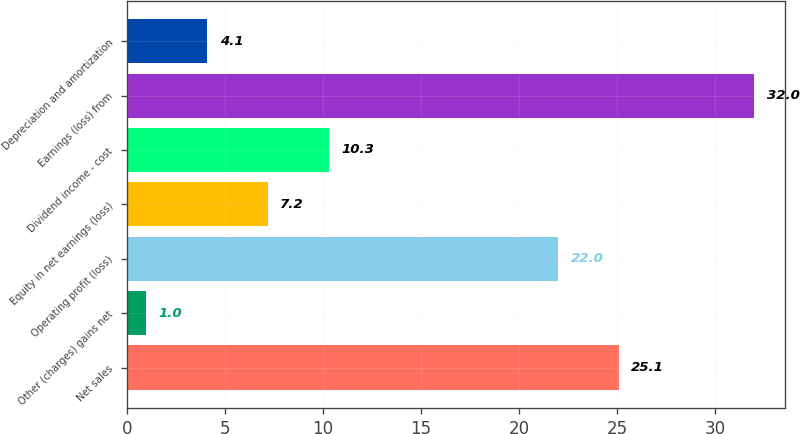Convert chart. <chart><loc_0><loc_0><loc_500><loc_500><bar_chart><fcel>Net sales<fcel>Other (charges) gains net<fcel>Operating profit (loss)<fcel>Equity in net earnings (loss)<fcel>Dividend income - cost<fcel>Earnings (loss) from<fcel>Depreciation and amortization<nl><fcel>25.1<fcel>1<fcel>22<fcel>7.2<fcel>10.3<fcel>32<fcel>4.1<nl></chart> 